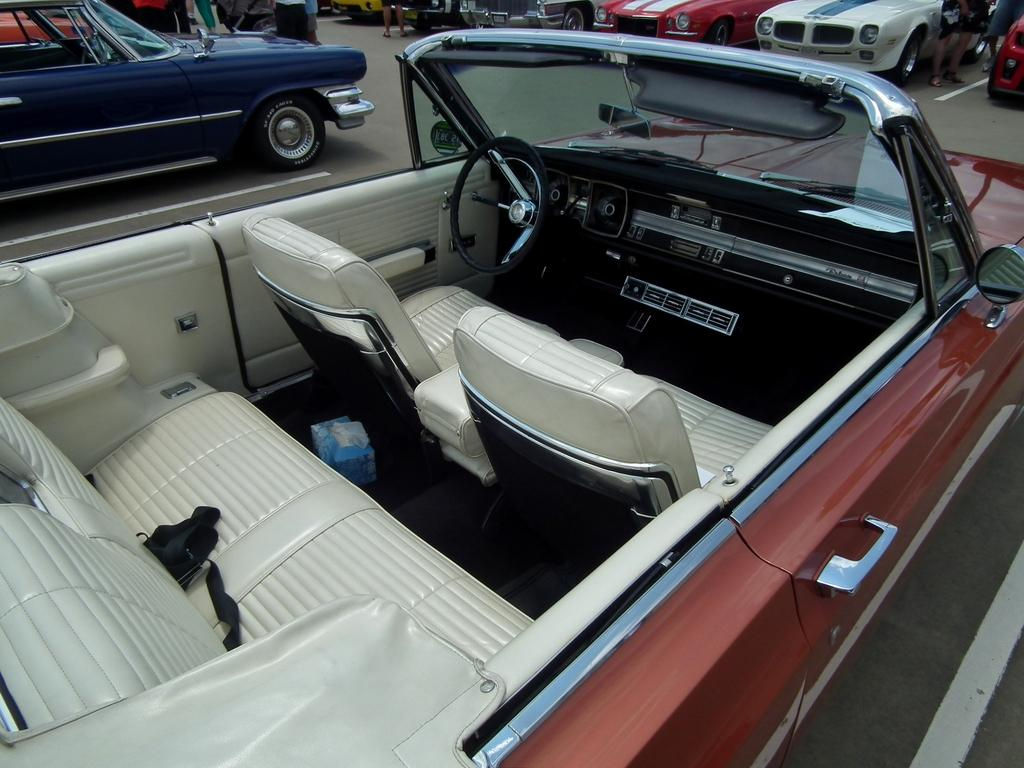What type of vehicles can be seen on the land in the image? There are cars on the land in the image. Can you describe the people visible at the top of the image? Unfortunately, the facts provided do not give any details about the people visible at the top of the image. What is the primary focus of the image? The primary focus of the image is the cars on the land. What type of education is being offered to the cars in the image? There is no education being offered to the cars in the image, as cars are inanimate objects and cannot receive education. 